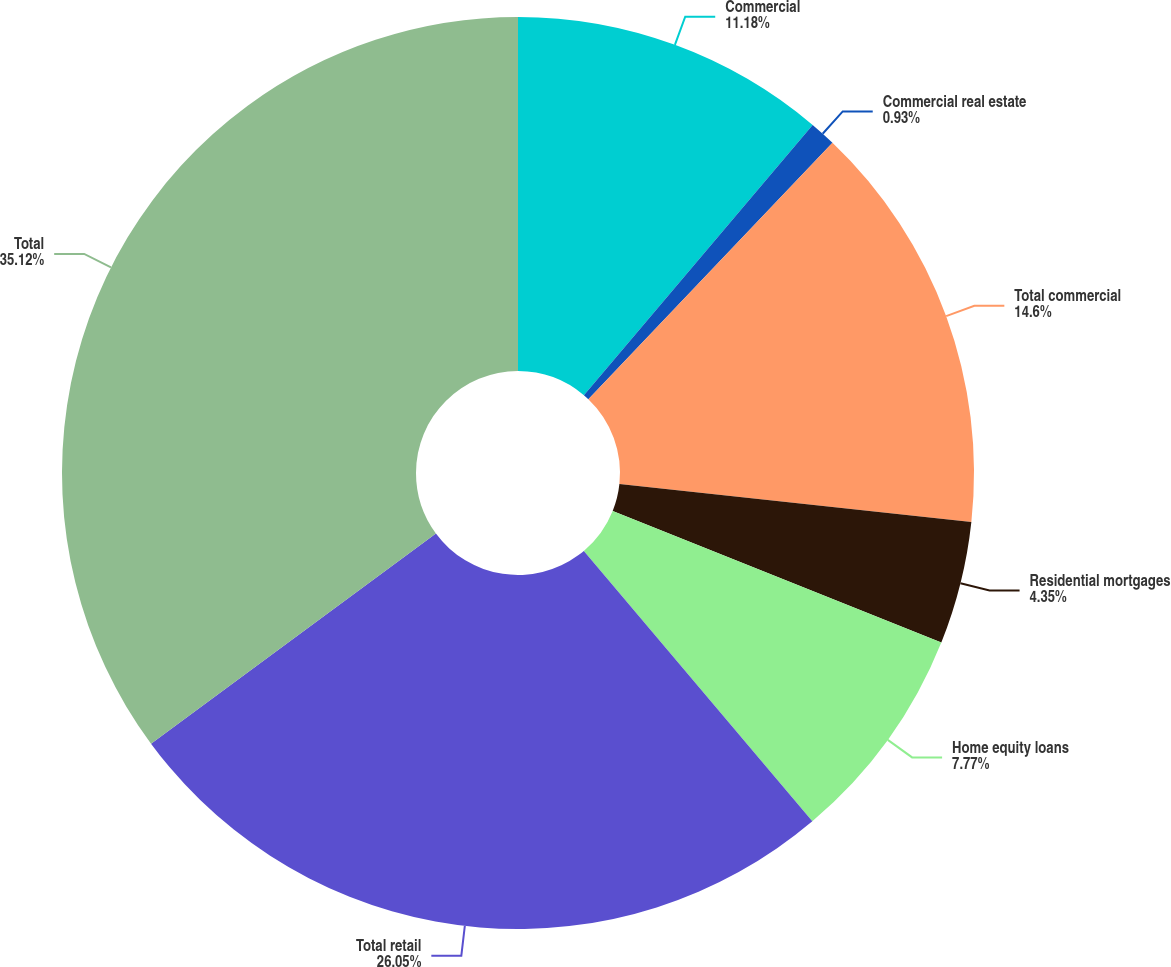Convert chart. <chart><loc_0><loc_0><loc_500><loc_500><pie_chart><fcel>Commercial<fcel>Commercial real estate<fcel>Total commercial<fcel>Residential mortgages<fcel>Home equity loans<fcel>Total retail<fcel>Total<nl><fcel>11.18%<fcel>0.93%<fcel>14.6%<fcel>4.35%<fcel>7.77%<fcel>26.05%<fcel>35.11%<nl></chart> 